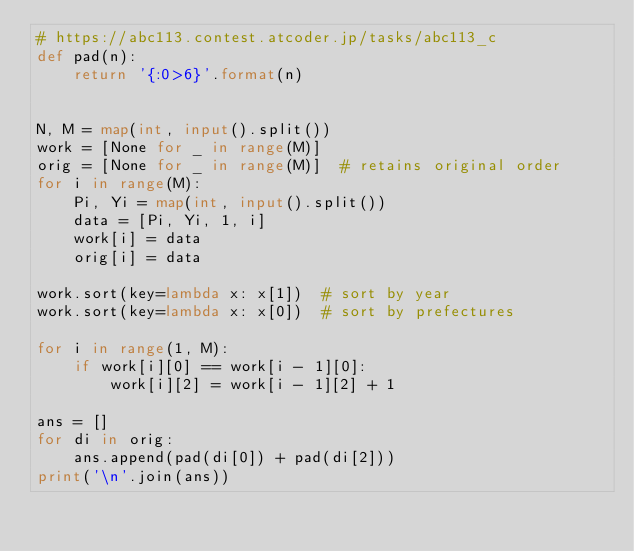<code> <loc_0><loc_0><loc_500><loc_500><_Python_># https://abc113.contest.atcoder.jp/tasks/abc113_c
def pad(n):
    return '{:0>6}'.format(n)


N, M = map(int, input().split())
work = [None for _ in range(M)]
orig = [None for _ in range(M)]  # retains original order
for i in range(M):
    Pi, Yi = map(int, input().split())
    data = [Pi, Yi, 1, i]
    work[i] = data
    orig[i] = data

work.sort(key=lambda x: x[1])  # sort by year
work.sort(key=lambda x: x[0])  # sort by prefectures

for i in range(1, M):
    if work[i][0] == work[i - 1][0]:
        work[i][2] = work[i - 1][2] + 1

ans = []
for di in orig:
    ans.append(pad(di[0]) + pad(di[2]))
print('\n'.join(ans))
</code> 